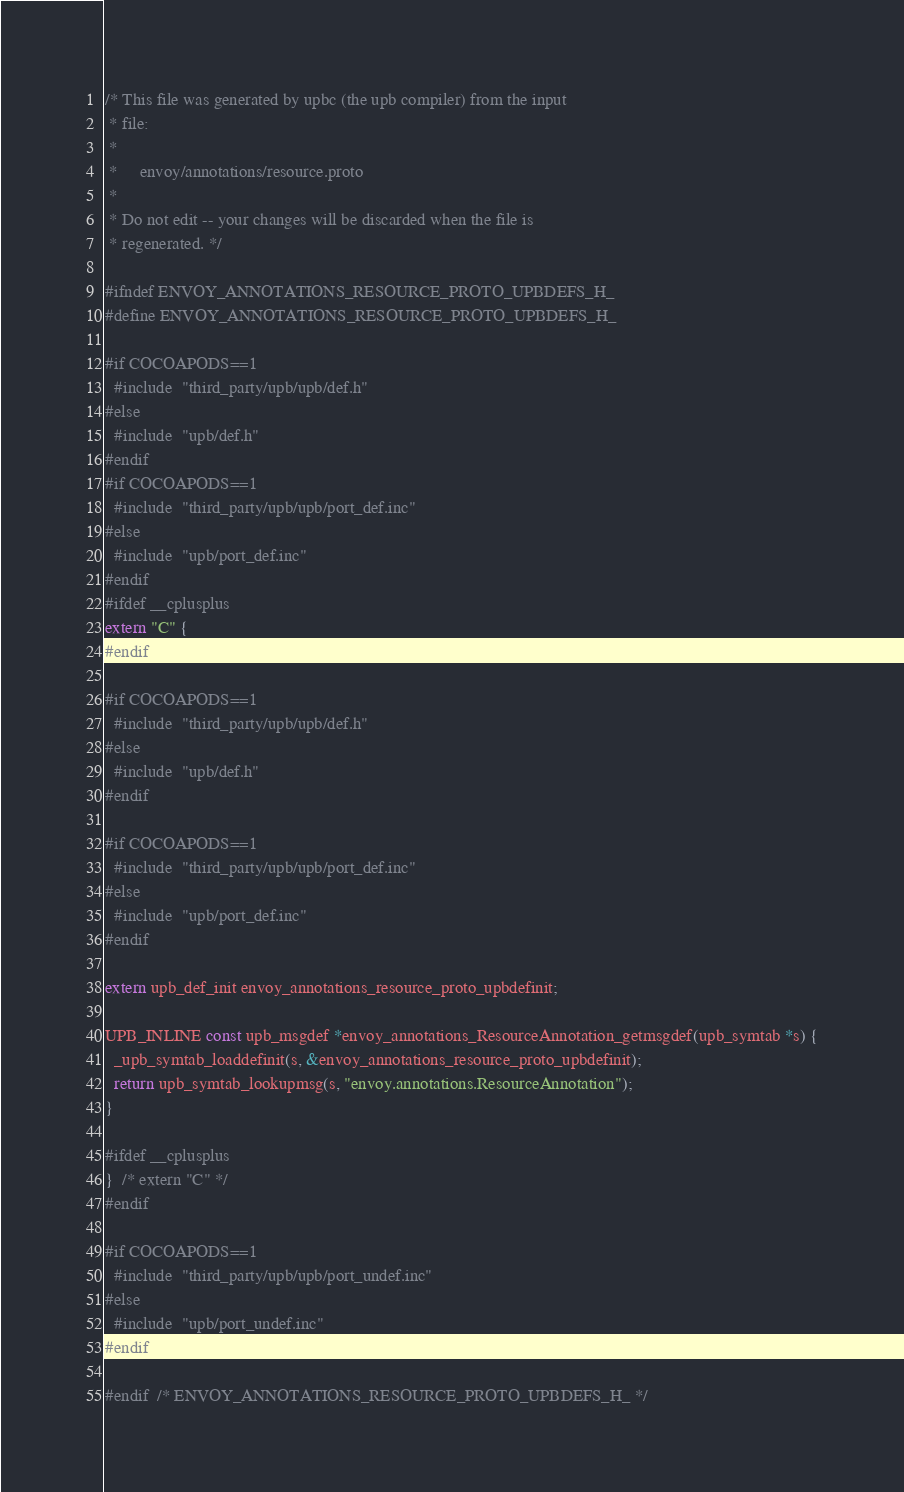Convert code to text. <code><loc_0><loc_0><loc_500><loc_500><_C_>/* This file was generated by upbc (the upb compiler) from the input
 * file:
 *
 *     envoy/annotations/resource.proto
 *
 * Do not edit -- your changes will be discarded when the file is
 * regenerated. */

#ifndef ENVOY_ANNOTATIONS_RESOURCE_PROTO_UPBDEFS_H_
#define ENVOY_ANNOTATIONS_RESOURCE_PROTO_UPBDEFS_H_

#if COCOAPODS==1
  #include  "third_party/upb/upb/def.h"
#else
  #include  "upb/def.h"
#endif
#if COCOAPODS==1
  #include  "third_party/upb/upb/port_def.inc"
#else
  #include  "upb/port_def.inc"
#endif
#ifdef __cplusplus
extern "C" {
#endif

#if COCOAPODS==1
  #include  "third_party/upb/upb/def.h"
#else
  #include  "upb/def.h"
#endif

#if COCOAPODS==1
  #include  "third_party/upb/upb/port_def.inc"
#else
  #include  "upb/port_def.inc"
#endif

extern upb_def_init envoy_annotations_resource_proto_upbdefinit;

UPB_INLINE const upb_msgdef *envoy_annotations_ResourceAnnotation_getmsgdef(upb_symtab *s) {
  _upb_symtab_loaddefinit(s, &envoy_annotations_resource_proto_upbdefinit);
  return upb_symtab_lookupmsg(s, "envoy.annotations.ResourceAnnotation");
}

#ifdef __cplusplus
}  /* extern "C" */
#endif

#if COCOAPODS==1
  #include  "third_party/upb/upb/port_undef.inc"
#else
  #include  "upb/port_undef.inc"
#endif

#endif  /* ENVOY_ANNOTATIONS_RESOURCE_PROTO_UPBDEFS_H_ */
</code> 